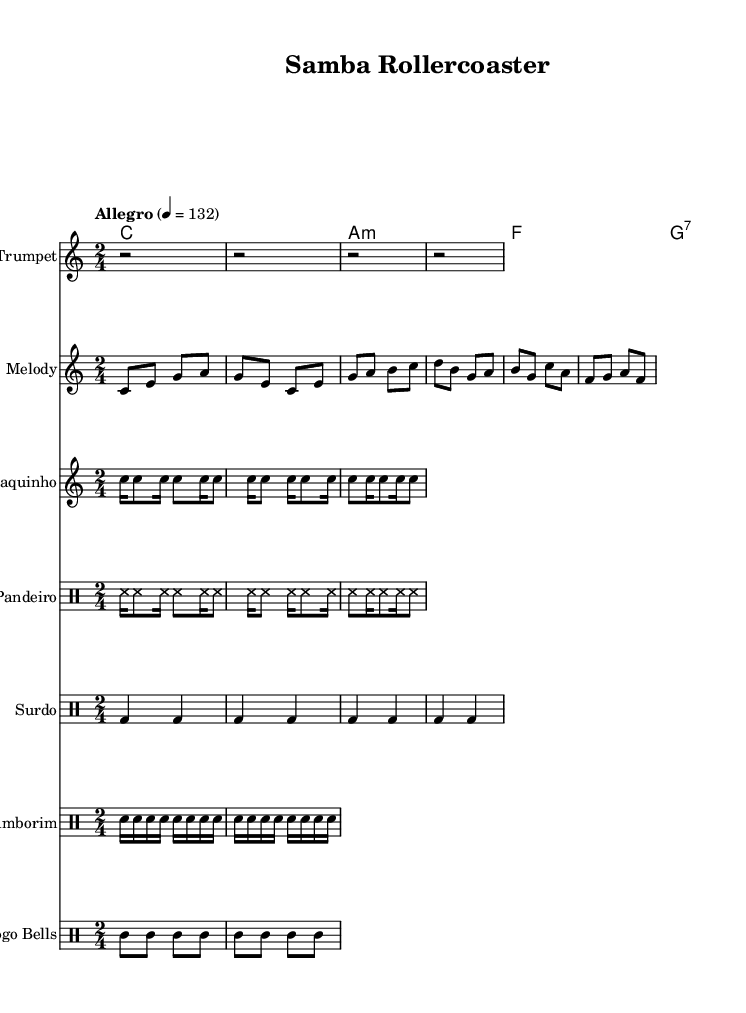What is the key signature of this music? The key signature is C major, which has no sharps or flats.
Answer: C major What is the time signature of this piece? The time signature is indicated as 2/4, meaning there are 2 beats in each measure and the quarter note receives one beat.
Answer: 2/4 What is the tempo marking for this composition? The tempo marking "Allegro" signifies a fast and lively tempo, specifically given as a quarter note equals 132 beats per minute.
Answer: Allegro How many different instruments are featured in the score? The score includes a melody instrument, trumpets, cavaquinho, and several percussion instruments: pandeiro, surdo, tamborim, and agogo bells, totaling seven instruments.
Answer: Seven Which chord is played in the first measure? The first measure shows a C major chord being played as indicated in the chord symbols at the beginning of the score.
Answer: C What rhythmic pattern is repeated in the tamborim part? The tamborim part consists of a consistent pattern of snare notes repeated in a sixteenth note sequence, which provides a syncopated feeling typical in samba rhythms.
Answer: Snare notes Which genre does this sheet music represent? The upbeat nature of the rhythm and instrumentation, along with the samba style indicated, aligns it clearly with Brazilian samba music, often associated with dance and festivity like amusement parks.
Answer: Brazilian samba 